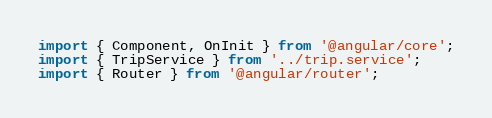<code> <loc_0><loc_0><loc_500><loc_500><_TypeScript_>import { Component, OnInit } from '@angular/core';
import { TripService } from '../trip.service';
import { Router } from '@angular/router';</code> 